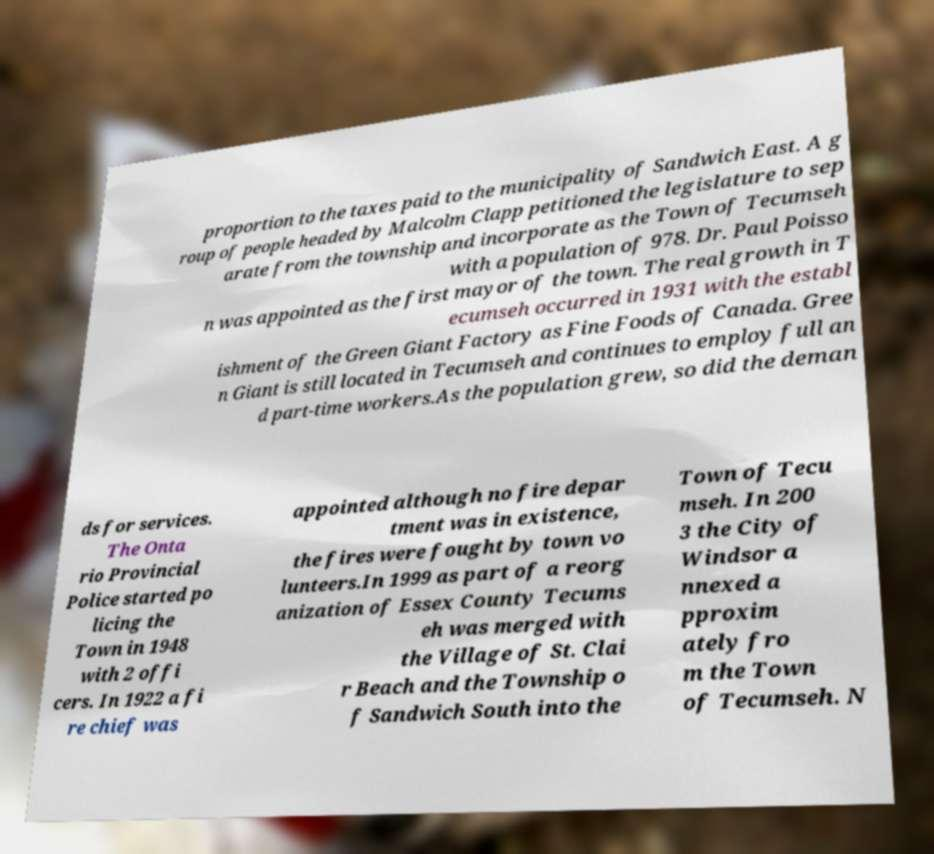Could you extract and type out the text from this image? proportion to the taxes paid to the municipality of Sandwich East. A g roup of people headed by Malcolm Clapp petitioned the legislature to sep arate from the township and incorporate as the Town of Tecumseh with a population of 978. Dr. Paul Poisso n was appointed as the first mayor of the town. The real growth in T ecumseh occurred in 1931 with the establ ishment of the Green Giant Factory as Fine Foods of Canada. Gree n Giant is still located in Tecumseh and continues to employ full an d part-time workers.As the population grew, so did the deman ds for services. The Onta rio Provincial Police started po licing the Town in 1948 with 2 offi cers. In 1922 a fi re chief was appointed although no fire depar tment was in existence, the fires were fought by town vo lunteers.In 1999 as part of a reorg anization of Essex County Tecums eh was merged with the Village of St. Clai r Beach and the Township o f Sandwich South into the Town of Tecu mseh. In 200 3 the City of Windsor a nnexed a pproxim ately fro m the Town of Tecumseh. N 